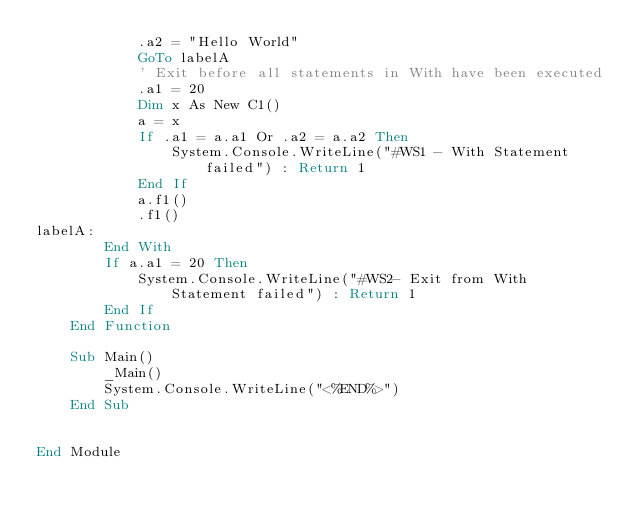<code> <loc_0><loc_0><loc_500><loc_500><_VisualBasic_>            .a2 = "Hello World"
            GoTo labelA
            ' Exit before all statements in With have been executed  
            .a1 = 20
            Dim x As New C1()
            a = x
            If .a1 = a.a1 Or .a2 = a.a2 Then
                System.Console.WriteLine("#WS1 - With Statement failed") : Return 1
            End If
            a.f1()
            .f1()
labelA:
        End With
        If a.a1 = 20 Then
            System.Console.WriteLine("#WS2- Exit from With Statement failed") : Return 1
        End If
    End Function

	Sub Main()
		_Main()
		System.Console.WriteLine("<%END%>")
	End Sub


End Module
</code> 